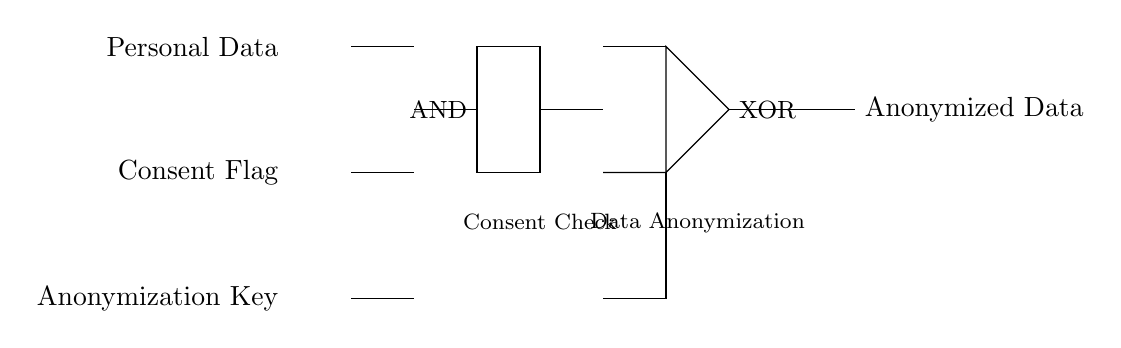What are the input signals of this circuit? The circuit has three input signals: Personal Data, Consent Flag, and Anonymization Key, which are labeled at the left side of the circuit diagram.
Answer: Personal Data, Consent Flag, Anonymization Key What type of logic gate is used for the consent check? The consent check is implemented using an AND gate, which is indicated by the label "AND" in the diagram. The AND gate requires all inputs to be true for its output to be true.
Answer: AND What triggers the XOR gate in this circuit? The XOR gate is triggered by the outputs from the AND gate and the Anonymization Key. An XOR gate produces a true output if the number of true inputs is odd, which in this case depends on the inputs it receives from the previous stage.
Answer: The output of the AND gate and the Anonymization Key What is the output of the circuit? The output of the circuit is labeled as Anonymized Data, which represents the processed data after passing through the combination of logic gates based on the inputs provided.
Answer: Anonymized Data How many logic gates are there in the circuit? There are two logic gates in the circuit: one AND gate and one XOR gate, both of which perform specific functions based on the different inputs received.
Answer: Two What role does the Consent Flag play in the circuit? The Consent Flag is crucial as it influences the output of the AND gate; if the Consent Flag is false, it will prevent the AND gate from passing any signal further, thereby affecting the subsequent data processing.
Answer: Influences AND gate output 